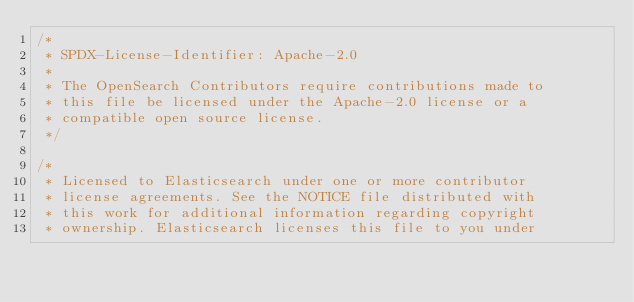<code> <loc_0><loc_0><loc_500><loc_500><_Java_>/*
 * SPDX-License-Identifier: Apache-2.0
 *
 * The OpenSearch Contributors require contributions made to
 * this file be licensed under the Apache-2.0 license or a
 * compatible open source license.
 */

/*
 * Licensed to Elasticsearch under one or more contributor
 * license agreements. See the NOTICE file distributed with
 * this work for additional information regarding copyright
 * ownership. Elasticsearch licenses this file to you under</code> 